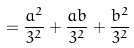Convert formula to latex. <formula><loc_0><loc_0><loc_500><loc_500>= \frac { a ^ { 2 } } { 3 ^ { 2 } } + \frac { a b } { 3 ^ { 2 } } + \frac { b ^ { 2 } } { 3 ^ { 2 } }</formula> 